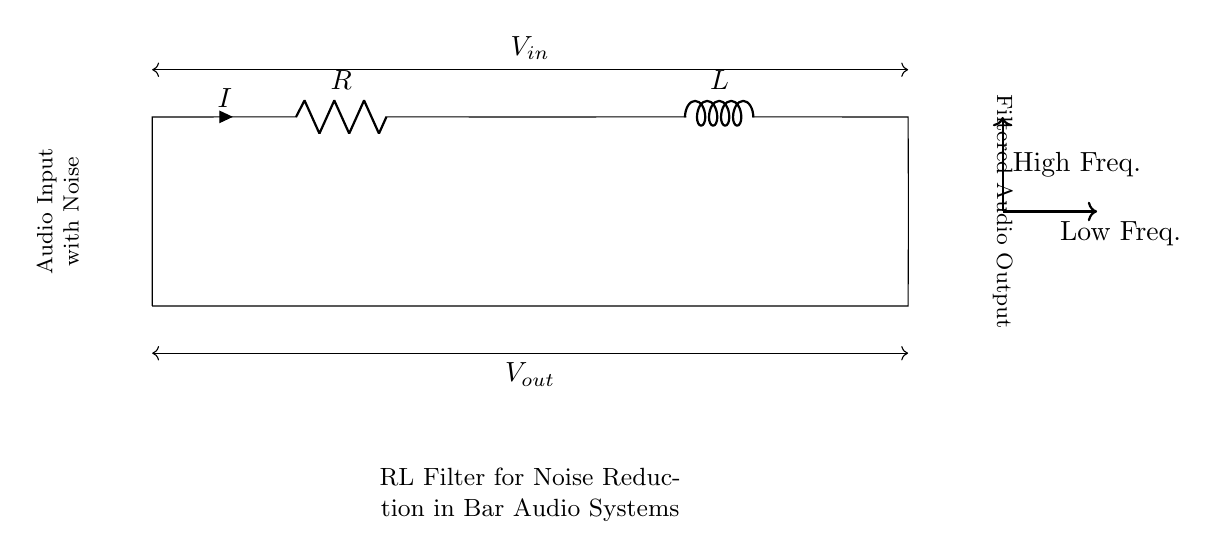What type of circuit is this? This circuit is a Resistor-Inductor or RL circuit, which combines a resistor and an inductor in series for filtering purposes.
Answer: RL filter What are the components of the circuit? The circuit consists of a resistor, an inductor, and two terminals for input and output voltage.
Answer: Resistor and inductor What is the purpose of this circuit? The purpose of this circuit is to filter noise from audio signals, allowing lower frequencies to pass while attenuating higher frequencies.
Answer: Noise reduction What is the current direction indicated in the circuit? The current direction is from the input to the output, as indicated by the arrow labeled "I" pointing from the resistor to the inductor, then to the ground.
Answer: From input to output How does the circuit affect high frequencies? The circuit attenuates high frequencies, which means it reduces their amplitude in the output signal compared to the input signal.
Answer: Attenuates What is the relationship between input and output voltage? The output voltage is expected to be lower than the input voltage due to the filtering action of the resistor and inductor, especially for high-frequency noise.
Answer: Lower voltage What happens if the resistance is increased in this circuit? Increasing the resistance would generally reduce the overall current in the circuit and may lead to greater attenuation of higher frequencies, enhancing the filtering effect.
Answer: Greater attenuation 